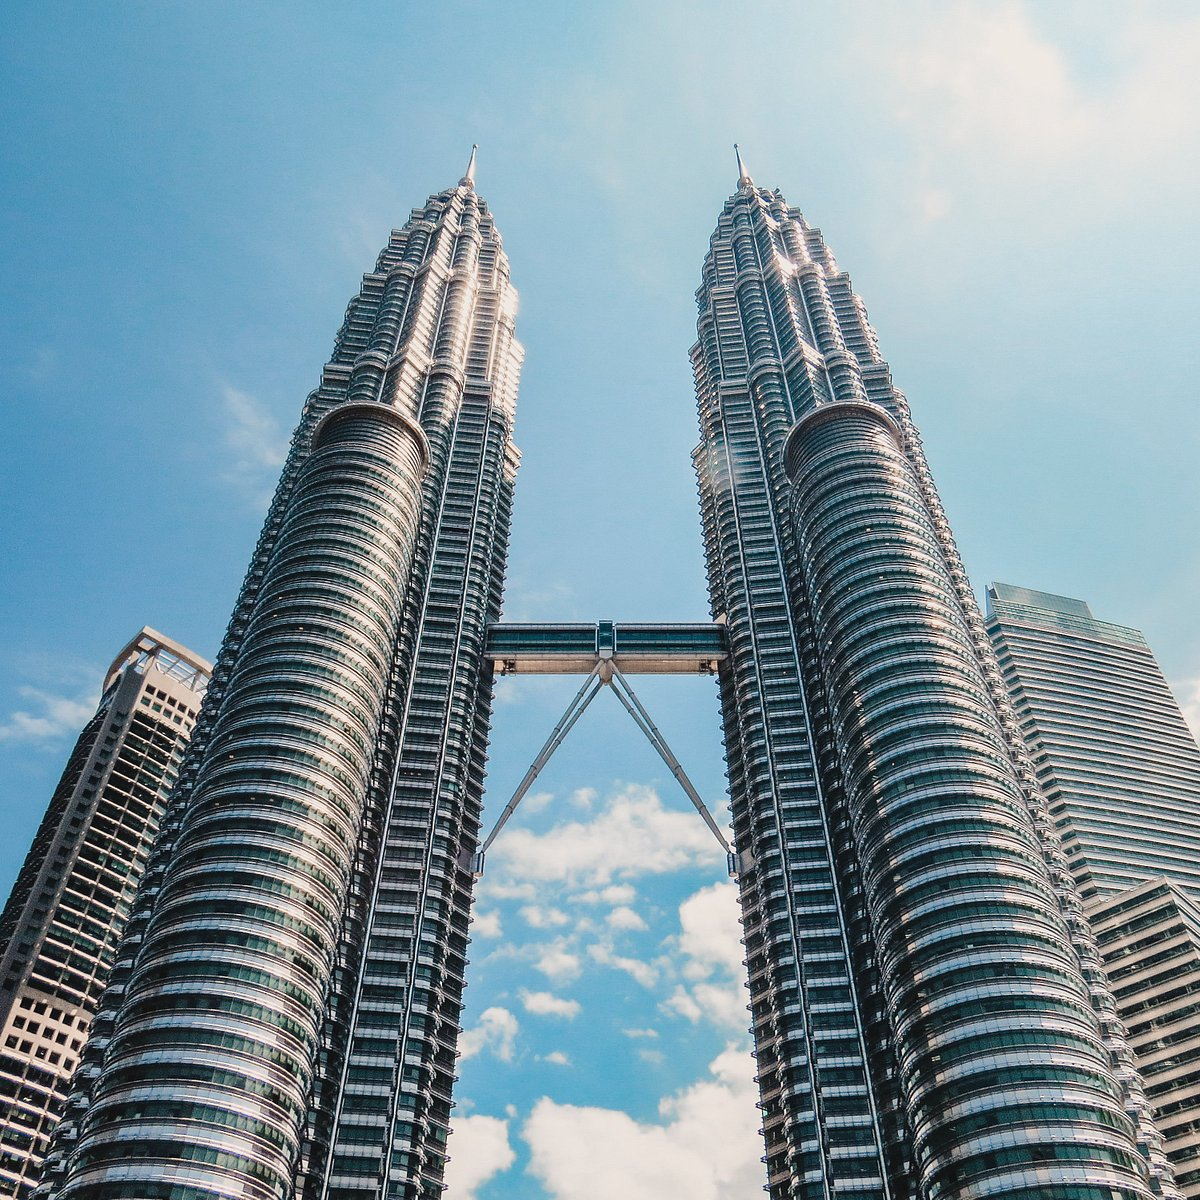Write a detailed description of the given image. The image captures the majestic Petronas Twin Towers, a renowned landmark in Kuala Lumpur, Malaysia. The towers, constructed of steel and glass, soar into the sky, their height accentuated by the perspective of the photo taken from below. A skybridge, a distinctive feature of the towers, connects them at the 41st and 42nd floors, providing a unique architectural element. The backdrop of a blue sky scattered with white clouds contrasts with the modern, metallic structures, highlighting their grandeur. The image encapsulates the essence of this iconic landmark, presenting a blend of architectural brilliance and natural beauty. 